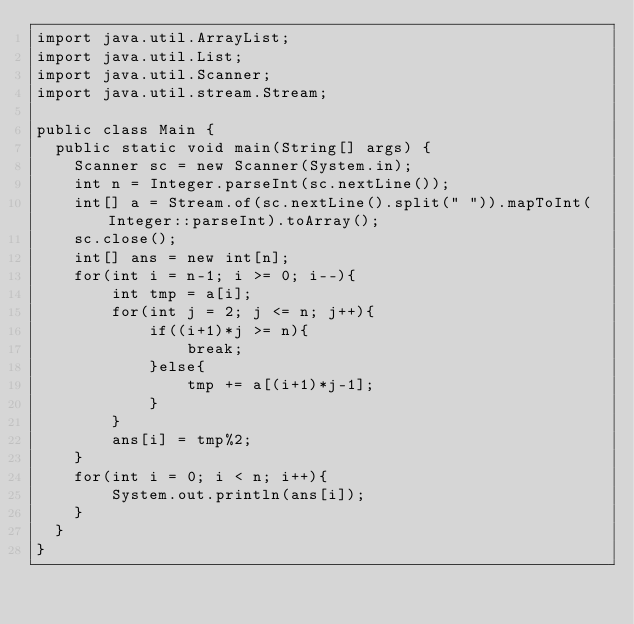<code> <loc_0><loc_0><loc_500><loc_500><_Java_>import java.util.ArrayList;
import java.util.List;
import java.util.Scanner;
import java.util.stream.Stream;
 
public class Main {
  public static void main(String[] args) {
    Scanner sc = new Scanner(System.in);
    int n = Integer.parseInt(sc.nextLine());
    int[] a = Stream.of(sc.nextLine().split(" ")).mapToInt(Integer::parseInt).toArray();
    sc.close();
    int[] ans = new int[n];
    for(int i = n-1; i >= 0; i--){
        int tmp = a[i];
        for(int j = 2; j <= n; j++){
            if((i+1)*j >= n){
                break;
            }else{
                tmp += a[(i+1)*j-1];
            }
        }
        ans[i] = tmp%2;
    }
    for(int i = 0; i < n; i++){
        System.out.println(ans[i]);
    }
  }
}</code> 